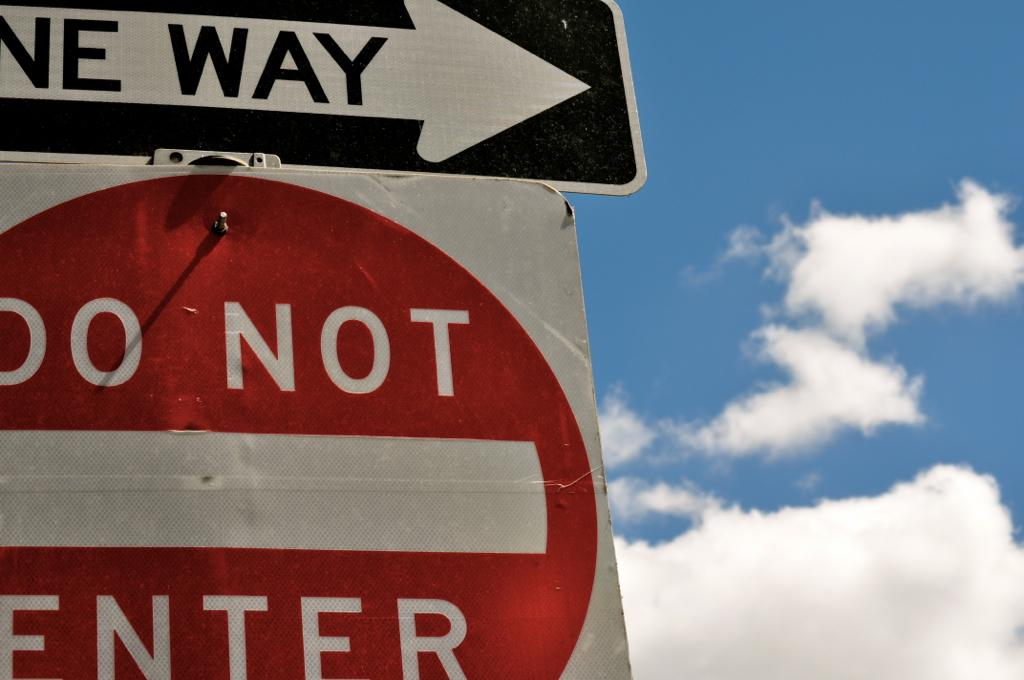<image>
Share a concise interpretation of the image provided. A blue sky with clouds provides the backdrop to a One Way and a Do Not Enter sign. 